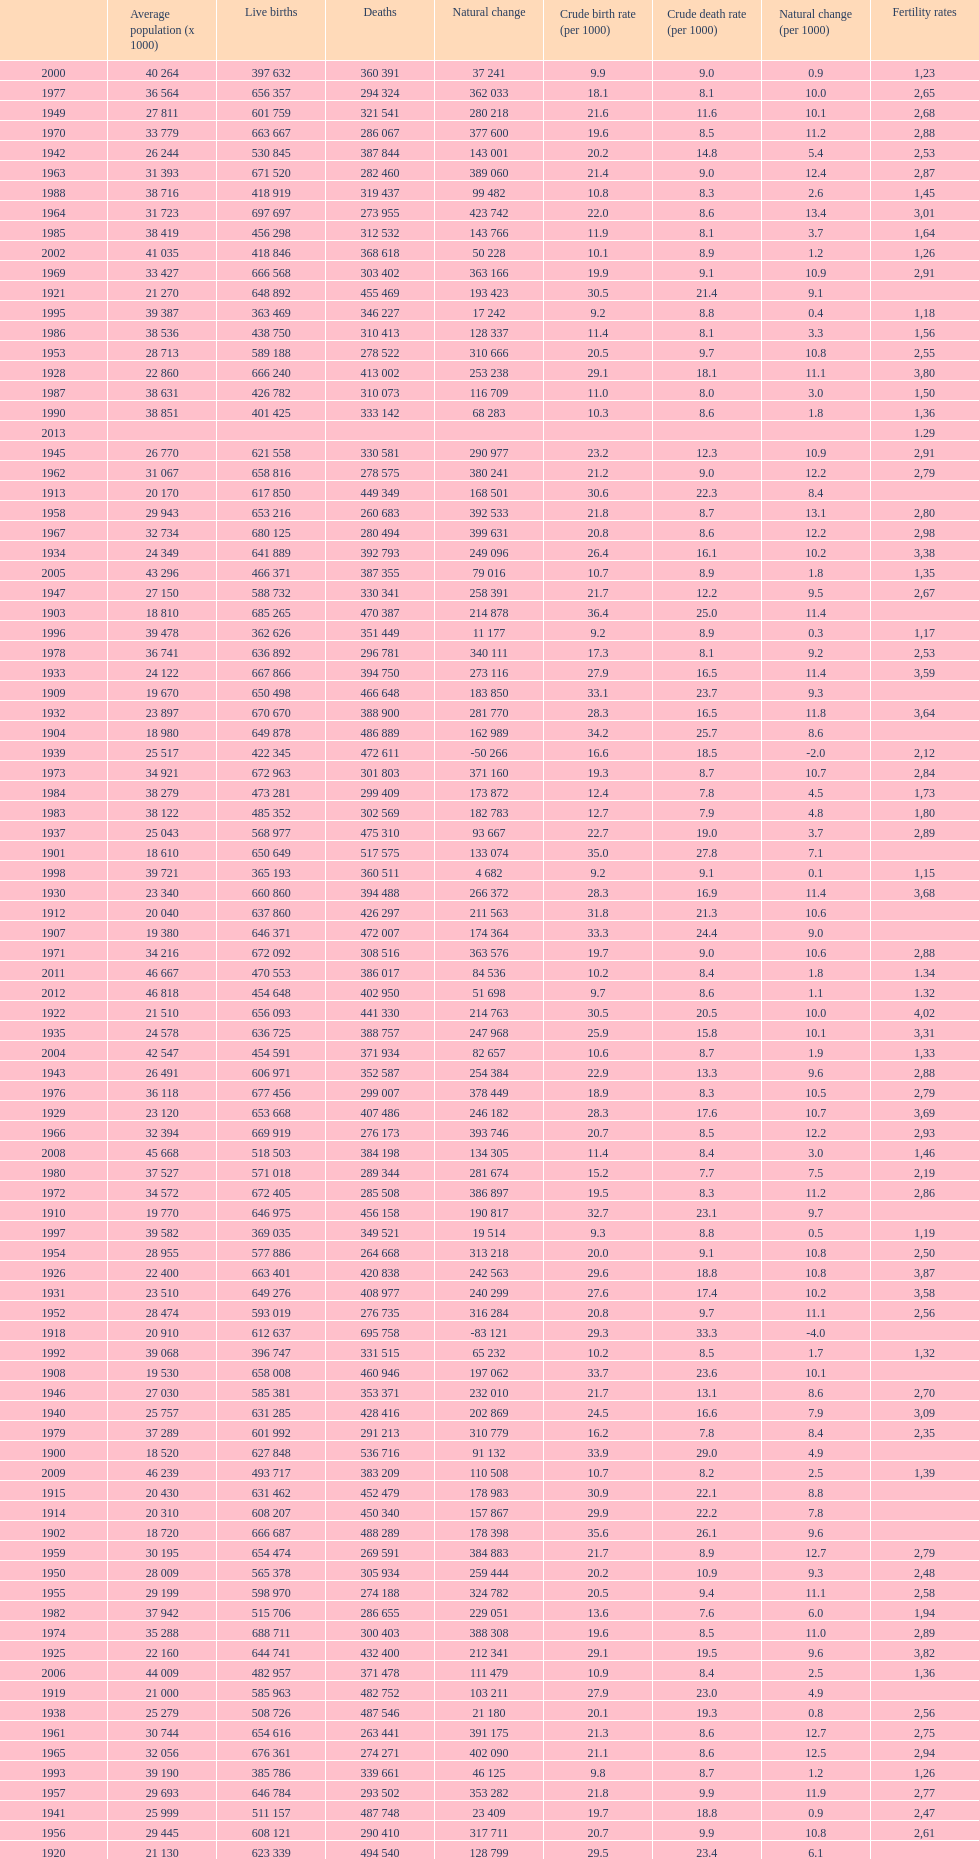Which year has a crude birth rate of 29.1 with a population of 22,860? 1928. 